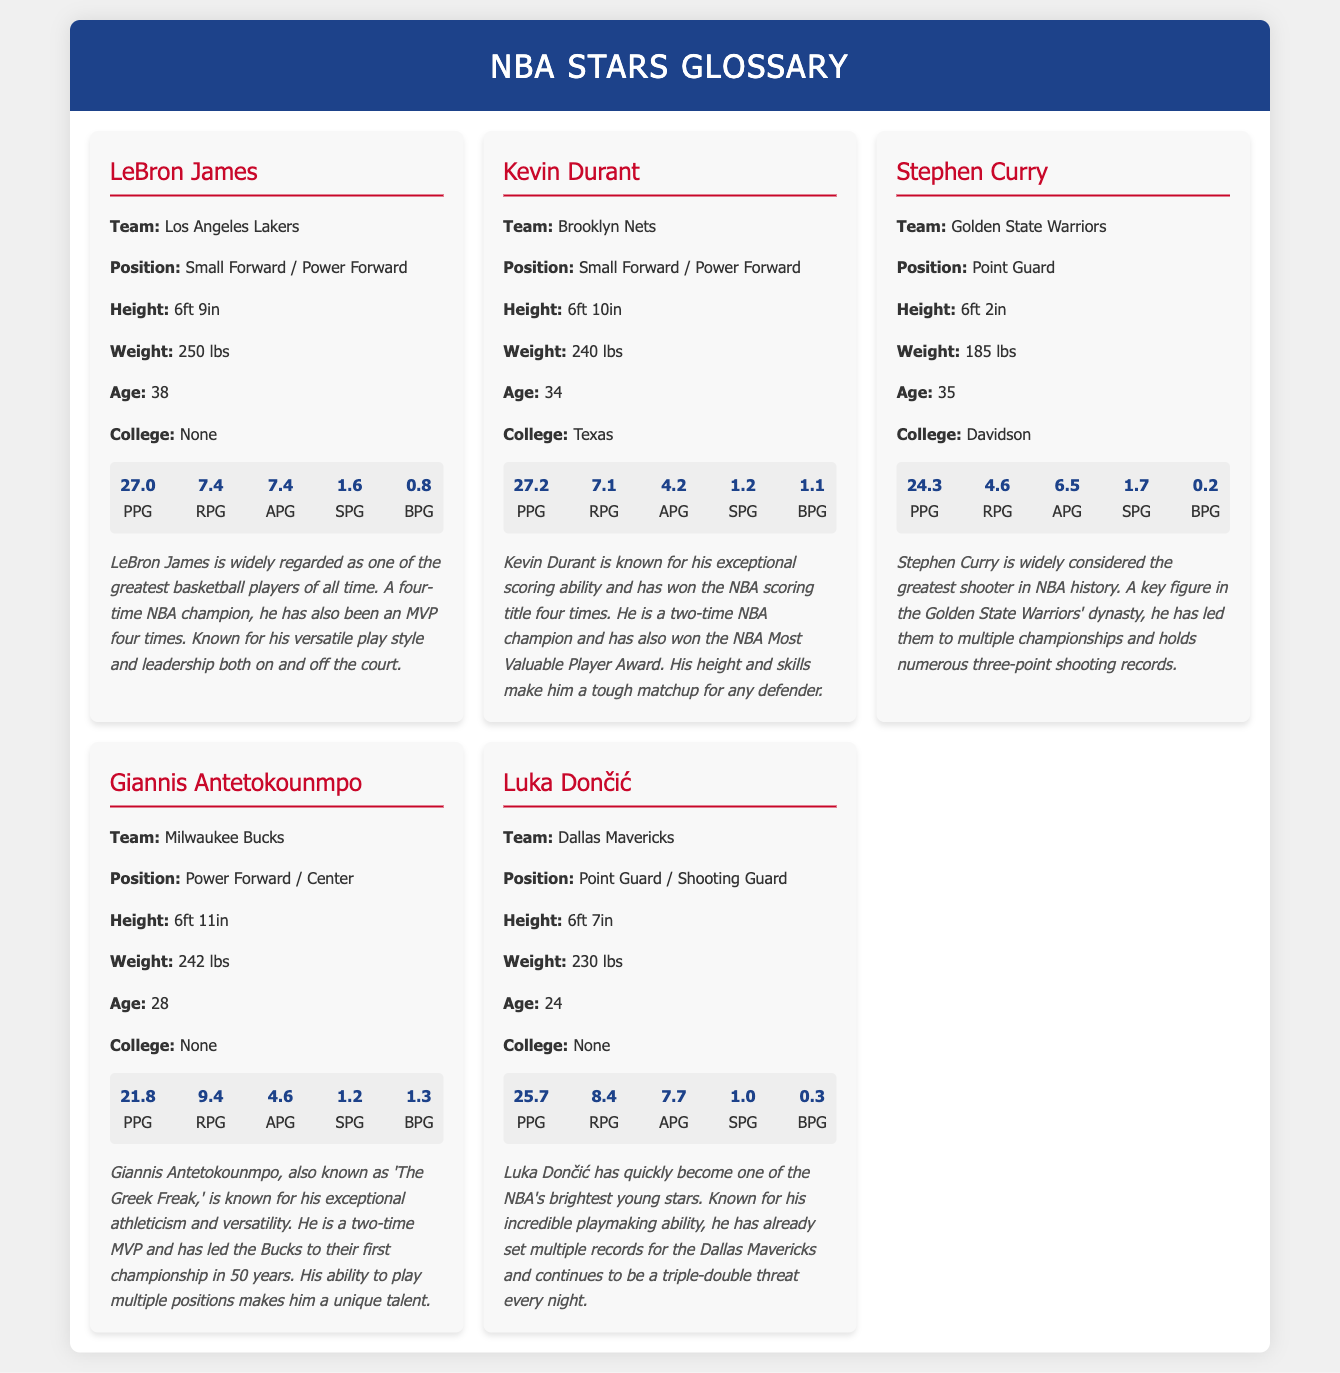What team does LeBron James play for? The document specifies that LeBron James plays for the Los Angeles Lakers.
Answer: Los Angeles Lakers How tall is Kevin Durant? The document indicates that Kevin Durant is 6ft 10in tall.
Answer: 6ft 10in What position does Stephen Curry play? According to the document, Stephen Curry plays as a Point Guard.
Answer: Point Guard How many points per game did Giannis Antetokounmpo average? The document states that Giannis Antetokounmpo averaged 21.8 points per game (PPG).
Answer: 21.8 Who is known as "The Greek Freak"? The document mentions Giannis Antetokounmpo as "The Greek Freak."
Answer: Giannis Antetokounmpo What is Luka Dončić's weight? The document provides that Luka Dončić weighs 230 lbs.
Answer: 230 lbs Which player has the highest assists per game? By comparing the stats, Luka Dončić has the highest assists per game at 7.7.
Answer: 7.7 How many NBA championships has LeBron James won? The document notes that LeBron James is a four-time NBA champion.
Answer: Four What college did Stephen Curry attend? The document specifies that Stephen Curry attended Davidson.
Answer: Davidson 